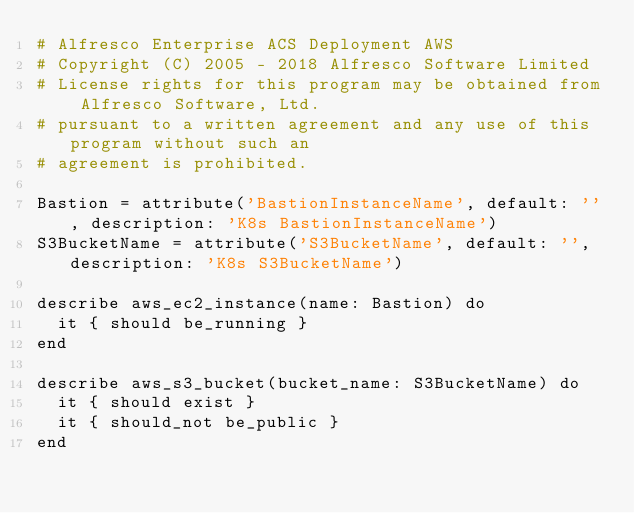Convert code to text. <code><loc_0><loc_0><loc_500><loc_500><_Ruby_># Alfresco Enterprise ACS Deployment AWS
# Copyright (C) 2005 - 2018 Alfresco Software Limited
# License rights for this program may be obtained from Alfresco Software, Ltd.
# pursuant to a written agreement and any use of this program without such an
# agreement is prohibited.

Bastion = attribute('BastionInstanceName', default: '', description: 'K8s BastionInstanceName')
S3BucketName = attribute('S3BucketName', default: '', description: 'K8s S3BucketName')

describe aws_ec2_instance(name: Bastion) do
  it { should be_running }
end

describe aws_s3_bucket(bucket_name: S3BucketName) do
  it { should exist }
  it { should_not be_public }
end</code> 